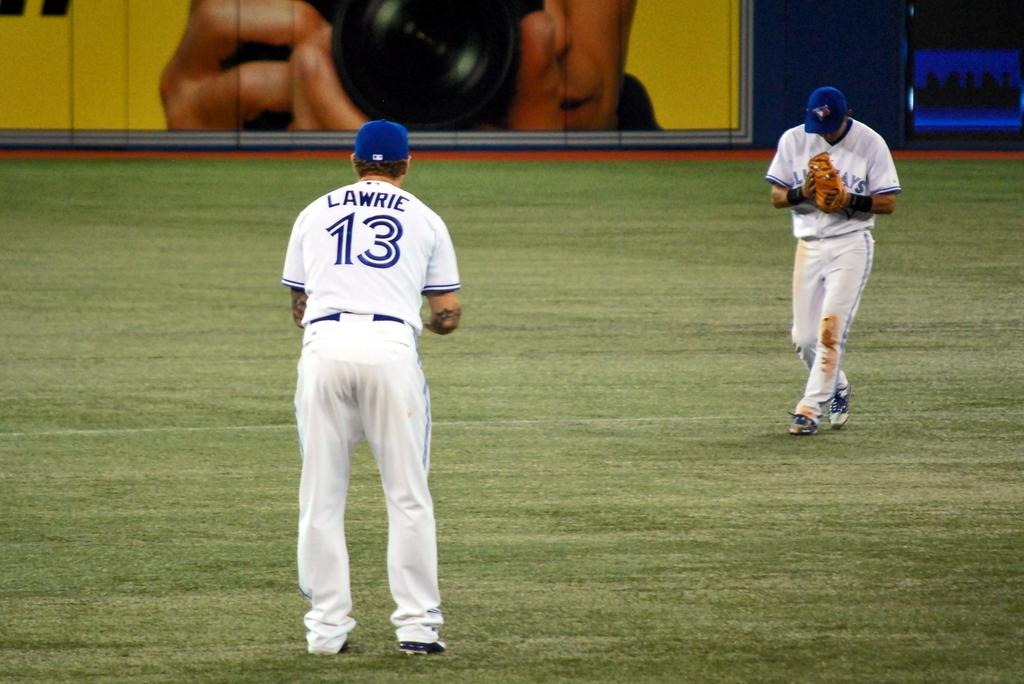<image>
Create a compact narrative representing the image presented. some baseball players and one with the number 13 on them 